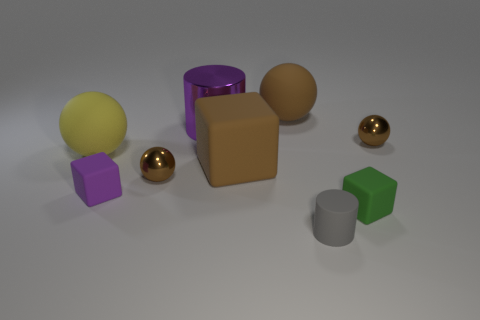There is a matte sphere that is the same color as the large rubber cube; what size is it?
Keep it short and to the point. Large. Is there a metal cylinder of the same size as the yellow ball?
Your response must be concise. Yes. Does the green matte object have the same shape as the tiny rubber thing that is on the left side of the large brown block?
Provide a succinct answer. Yes. There is a brown shiny thing in front of the yellow rubber sphere; is its size the same as the matte block on the left side of the purple shiny cylinder?
Offer a very short reply. Yes. What number of other objects are the same shape as the small green rubber thing?
Make the answer very short. 2. The large purple cylinder behind the brown metal ball on the right side of the gray rubber object is made of what material?
Your answer should be compact. Metal. How many rubber objects are either green objects or cylinders?
Provide a short and direct response. 2. Is there a small thing that is on the left side of the large brown rubber ball to the left of the rubber cylinder?
Ensure brevity in your answer.  Yes. What number of things are either large purple cylinders on the left side of the small green rubber cube or objects to the right of the purple cylinder?
Ensure brevity in your answer.  6. Is there any other thing that has the same color as the metallic cylinder?
Provide a short and direct response. Yes. 